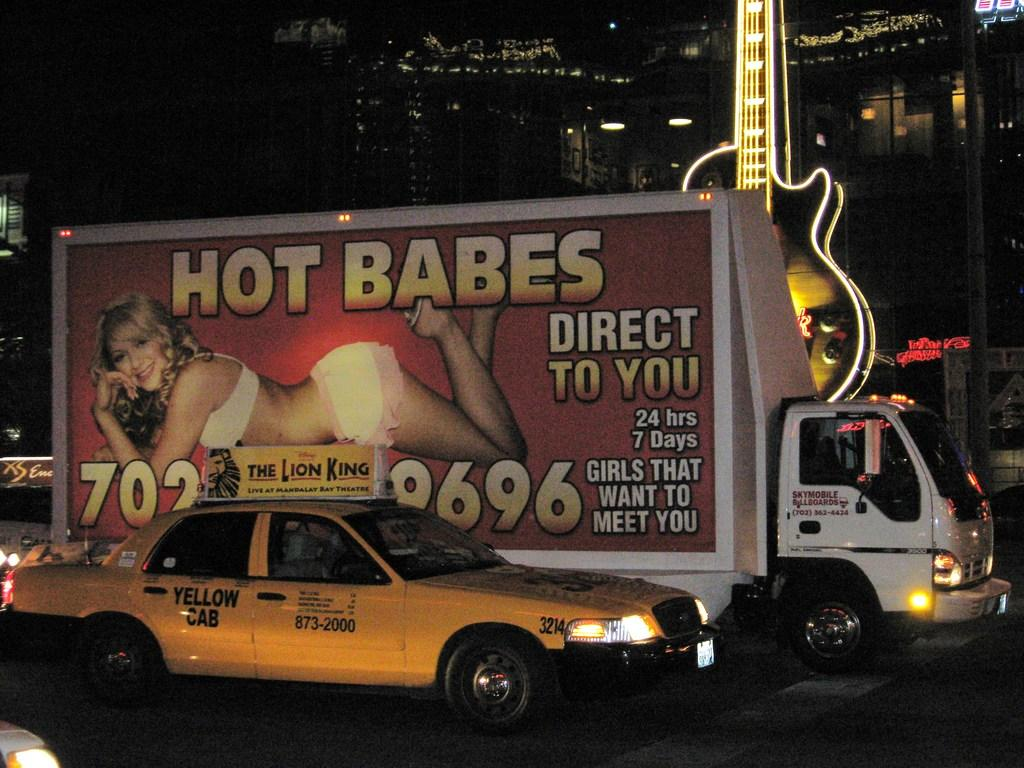<image>
Summarize the visual content of the image. A sign advertising "hot babes" includes a phone number. 